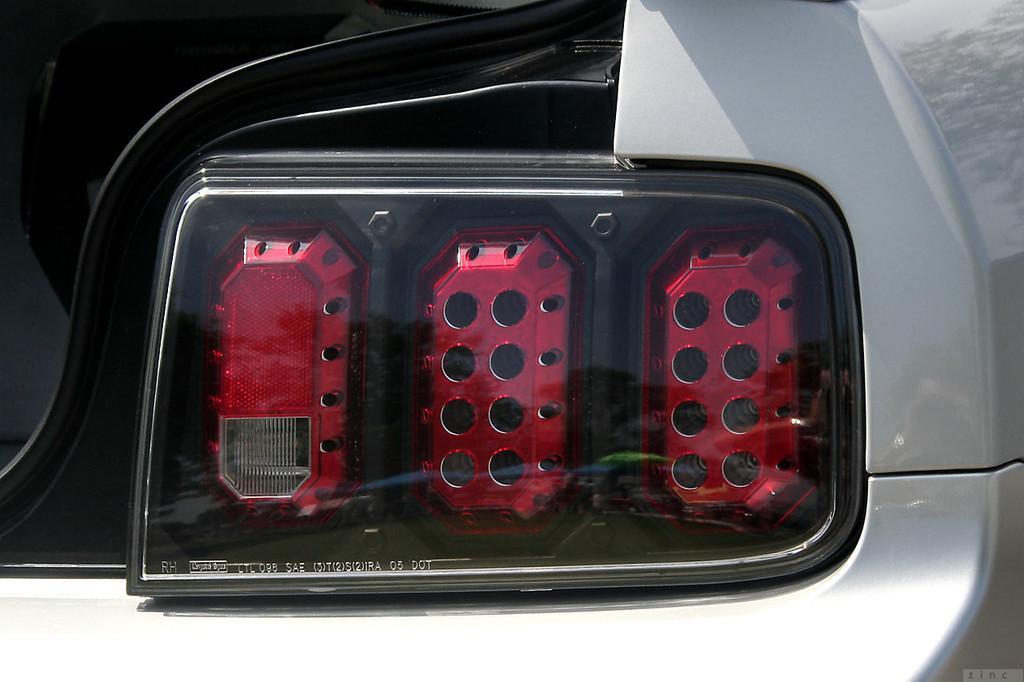In one or two sentences, can you explain what this image depicts? In this image I can see a vehicle and here I can see lights. 